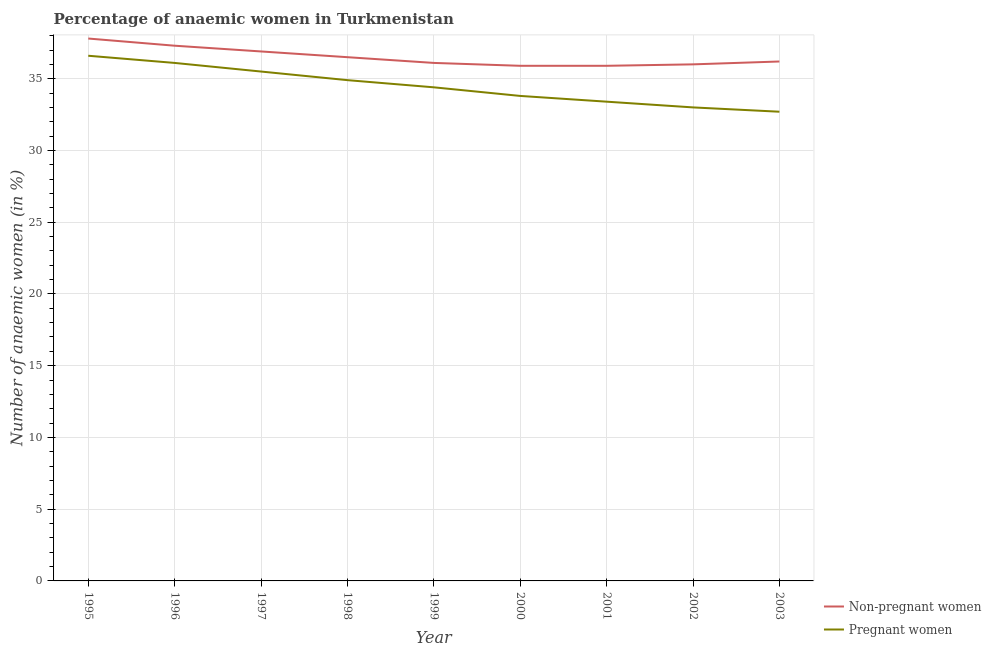What is the percentage of pregnant anaemic women in 2003?
Provide a short and direct response. 32.7. Across all years, what is the maximum percentage of non-pregnant anaemic women?
Offer a terse response. 37.8. Across all years, what is the minimum percentage of non-pregnant anaemic women?
Provide a short and direct response. 35.9. What is the total percentage of pregnant anaemic women in the graph?
Give a very brief answer. 310.4. What is the difference between the percentage of pregnant anaemic women in 1997 and that in 1998?
Ensure brevity in your answer.  0.6. What is the difference between the percentage of non-pregnant anaemic women in 2000 and the percentage of pregnant anaemic women in 1995?
Keep it short and to the point. -0.7. What is the average percentage of non-pregnant anaemic women per year?
Offer a very short reply. 36.51. In the year 2000, what is the difference between the percentage of pregnant anaemic women and percentage of non-pregnant anaemic women?
Provide a succinct answer. -2.1. What is the ratio of the percentage of non-pregnant anaemic women in 2001 to that in 2003?
Your answer should be compact. 0.99. What is the difference between the highest and the lowest percentage of non-pregnant anaemic women?
Provide a short and direct response. 1.9. In how many years, is the percentage of pregnant anaemic women greater than the average percentage of pregnant anaemic women taken over all years?
Offer a terse response. 4. Is the sum of the percentage of non-pregnant anaemic women in 2000 and 2003 greater than the maximum percentage of pregnant anaemic women across all years?
Provide a short and direct response. Yes. Is the percentage of pregnant anaemic women strictly greater than the percentage of non-pregnant anaemic women over the years?
Keep it short and to the point. No. Is the percentage of non-pregnant anaemic women strictly less than the percentage of pregnant anaemic women over the years?
Your response must be concise. No. How many lines are there?
Your answer should be very brief. 2. What is the difference between two consecutive major ticks on the Y-axis?
Make the answer very short. 5. Are the values on the major ticks of Y-axis written in scientific E-notation?
Ensure brevity in your answer.  No. Does the graph contain grids?
Provide a succinct answer. Yes. What is the title of the graph?
Offer a very short reply. Percentage of anaemic women in Turkmenistan. What is the label or title of the Y-axis?
Offer a terse response. Number of anaemic women (in %). What is the Number of anaemic women (in %) in Non-pregnant women in 1995?
Make the answer very short. 37.8. What is the Number of anaemic women (in %) of Pregnant women in 1995?
Offer a terse response. 36.6. What is the Number of anaemic women (in %) in Non-pregnant women in 1996?
Offer a terse response. 37.3. What is the Number of anaemic women (in %) in Pregnant women in 1996?
Make the answer very short. 36.1. What is the Number of anaemic women (in %) of Non-pregnant women in 1997?
Give a very brief answer. 36.9. What is the Number of anaemic women (in %) of Pregnant women in 1997?
Your response must be concise. 35.5. What is the Number of anaemic women (in %) in Non-pregnant women in 1998?
Your response must be concise. 36.5. What is the Number of anaemic women (in %) in Pregnant women in 1998?
Offer a terse response. 34.9. What is the Number of anaemic women (in %) in Non-pregnant women in 1999?
Offer a terse response. 36.1. What is the Number of anaemic women (in %) in Pregnant women in 1999?
Your response must be concise. 34.4. What is the Number of anaemic women (in %) in Non-pregnant women in 2000?
Your answer should be very brief. 35.9. What is the Number of anaemic women (in %) of Pregnant women in 2000?
Provide a succinct answer. 33.8. What is the Number of anaemic women (in %) of Non-pregnant women in 2001?
Offer a terse response. 35.9. What is the Number of anaemic women (in %) in Pregnant women in 2001?
Offer a very short reply. 33.4. What is the Number of anaemic women (in %) in Non-pregnant women in 2002?
Give a very brief answer. 36. What is the Number of anaemic women (in %) of Non-pregnant women in 2003?
Ensure brevity in your answer.  36.2. What is the Number of anaemic women (in %) in Pregnant women in 2003?
Give a very brief answer. 32.7. Across all years, what is the maximum Number of anaemic women (in %) of Non-pregnant women?
Provide a short and direct response. 37.8. Across all years, what is the maximum Number of anaemic women (in %) in Pregnant women?
Your answer should be compact. 36.6. Across all years, what is the minimum Number of anaemic women (in %) of Non-pregnant women?
Provide a short and direct response. 35.9. Across all years, what is the minimum Number of anaemic women (in %) of Pregnant women?
Your response must be concise. 32.7. What is the total Number of anaemic women (in %) of Non-pregnant women in the graph?
Your response must be concise. 328.6. What is the total Number of anaemic women (in %) in Pregnant women in the graph?
Keep it short and to the point. 310.4. What is the difference between the Number of anaemic women (in %) of Non-pregnant women in 1995 and that in 1996?
Ensure brevity in your answer.  0.5. What is the difference between the Number of anaemic women (in %) of Non-pregnant women in 1995 and that in 2000?
Provide a short and direct response. 1.9. What is the difference between the Number of anaemic women (in %) of Pregnant women in 1995 and that in 2000?
Provide a short and direct response. 2.8. What is the difference between the Number of anaemic women (in %) of Non-pregnant women in 1995 and that in 2001?
Your answer should be compact. 1.9. What is the difference between the Number of anaemic women (in %) in Non-pregnant women in 1995 and that in 2002?
Give a very brief answer. 1.8. What is the difference between the Number of anaemic women (in %) of Non-pregnant women in 1995 and that in 2003?
Your answer should be compact. 1.6. What is the difference between the Number of anaemic women (in %) in Pregnant women in 1995 and that in 2003?
Your answer should be compact. 3.9. What is the difference between the Number of anaemic women (in %) of Pregnant women in 1996 and that in 1997?
Ensure brevity in your answer.  0.6. What is the difference between the Number of anaemic women (in %) of Non-pregnant women in 1996 and that in 1998?
Provide a succinct answer. 0.8. What is the difference between the Number of anaemic women (in %) of Pregnant women in 1996 and that in 1998?
Offer a terse response. 1.2. What is the difference between the Number of anaemic women (in %) in Non-pregnant women in 1996 and that in 2003?
Provide a succinct answer. 1.1. What is the difference between the Number of anaemic women (in %) of Pregnant women in 1996 and that in 2003?
Keep it short and to the point. 3.4. What is the difference between the Number of anaemic women (in %) in Non-pregnant women in 1997 and that in 1998?
Your answer should be very brief. 0.4. What is the difference between the Number of anaemic women (in %) in Non-pregnant women in 1997 and that in 1999?
Your response must be concise. 0.8. What is the difference between the Number of anaemic women (in %) of Pregnant women in 1997 and that in 1999?
Make the answer very short. 1.1. What is the difference between the Number of anaemic women (in %) in Non-pregnant women in 1997 and that in 2000?
Provide a short and direct response. 1. What is the difference between the Number of anaemic women (in %) in Pregnant women in 1997 and that in 2000?
Give a very brief answer. 1.7. What is the difference between the Number of anaemic women (in %) of Non-pregnant women in 1997 and that in 2001?
Offer a very short reply. 1. What is the difference between the Number of anaemic women (in %) of Non-pregnant women in 1997 and that in 2002?
Provide a short and direct response. 0.9. What is the difference between the Number of anaemic women (in %) in Pregnant women in 1997 and that in 2002?
Offer a very short reply. 2.5. What is the difference between the Number of anaemic women (in %) of Non-pregnant women in 1998 and that in 1999?
Offer a very short reply. 0.4. What is the difference between the Number of anaemic women (in %) in Non-pregnant women in 1998 and that in 2001?
Your answer should be very brief. 0.6. What is the difference between the Number of anaemic women (in %) of Pregnant women in 1998 and that in 2001?
Give a very brief answer. 1.5. What is the difference between the Number of anaemic women (in %) in Non-pregnant women in 1998 and that in 2002?
Give a very brief answer. 0.5. What is the difference between the Number of anaemic women (in %) in Pregnant women in 1998 and that in 2002?
Give a very brief answer. 1.9. What is the difference between the Number of anaemic women (in %) of Non-pregnant women in 1998 and that in 2003?
Make the answer very short. 0.3. What is the difference between the Number of anaemic women (in %) in Pregnant women in 1999 and that in 2000?
Offer a very short reply. 0.6. What is the difference between the Number of anaemic women (in %) in Non-pregnant women in 1999 and that in 2002?
Offer a terse response. 0.1. What is the difference between the Number of anaemic women (in %) of Pregnant women in 1999 and that in 2002?
Provide a succinct answer. 1.4. What is the difference between the Number of anaemic women (in %) in Pregnant women in 1999 and that in 2003?
Provide a succinct answer. 1.7. What is the difference between the Number of anaemic women (in %) of Non-pregnant women in 2000 and that in 2001?
Your answer should be very brief. 0. What is the difference between the Number of anaemic women (in %) in Non-pregnant women in 2000 and that in 2003?
Provide a succinct answer. -0.3. What is the difference between the Number of anaemic women (in %) in Non-pregnant women in 2001 and that in 2002?
Give a very brief answer. -0.1. What is the difference between the Number of anaemic women (in %) of Non-pregnant women in 2001 and that in 2003?
Make the answer very short. -0.3. What is the difference between the Number of anaemic women (in %) of Pregnant women in 2001 and that in 2003?
Offer a very short reply. 0.7. What is the difference between the Number of anaemic women (in %) of Non-pregnant women in 1995 and the Number of anaemic women (in %) of Pregnant women in 1997?
Provide a short and direct response. 2.3. What is the difference between the Number of anaemic women (in %) in Non-pregnant women in 1995 and the Number of anaemic women (in %) in Pregnant women in 1998?
Offer a very short reply. 2.9. What is the difference between the Number of anaemic women (in %) in Non-pregnant women in 1995 and the Number of anaemic women (in %) in Pregnant women in 2001?
Your answer should be very brief. 4.4. What is the difference between the Number of anaemic women (in %) in Non-pregnant women in 1995 and the Number of anaemic women (in %) in Pregnant women in 2003?
Your answer should be very brief. 5.1. What is the difference between the Number of anaemic women (in %) in Non-pregnant women in 1996 and the Number of anaemic women (in %) in Pregnant women in 1998?
Give a very brief answer. 2.4. What is the difference between the Number of anaemic women (in %) of Non-pregnant women in 1996 and the Number of anaemic women (in %) of Pregnant women in 2000?
Your response must be concise. 3.5. What is the difference between the Number of anaemic women (in %) in Non-pregnant women in 1996 and the Number of anaemic women (in %) in Pregnant women in 2001?
Keep it short and to the point. 3.9. What is the difference between the Number of anaemic women (in %) of Non-pregnant women in 1996 and the Number of anaemic women (in %) of Pregnant women in 2002?
Offer a very short reply. 4.3. What is the difference between the Number of anaemic women (in %) of Non-pregnant women in 1997 and the Number of anaemic women (in %) of Pregnant women in 1999?
Make the answer very short. 2.5. What is the difference between the Number of anaemic women (in %) of Non-pregnant women in 1997 and the Number of anaemic women (in %) of Pregnant women in 2000?
Your response must be concise. 3.1. What is the difference between the Number of anaemic women (in %) in Non-pregnant women in 1997 and the Number of anaemic women (in %) in Pregnant women in 2001?
Provide a succinct answer. 3.5. What is the difference between the Number of anaemic women (in %) of Non-pregnant women in 1997 and the Number of anaemic women (in %) of Pregnant women in 2002?
Provide a succinct answer. 3.9. What is the difference between the Number of anaemic women (in %) of Non-pregnant women in 1998 and the Number of anaemic women (in %) of Pregnant women in 2002?
Offer a terse response. 3.5. What is the difference between the Number of anaemic women (in %) in Non-pregnant women in 1999 and the Number of anaemic women (in %) in Pregnant women in 2001?
Ensure brevity in your answer.  2.7. What is the difference between the Number of anaemic women (in %) of Non-pregnant women in 1999 and the Number of anaemic women (in %) of Pregnant women in 2002?
Provide a succinct answer. 3.1. What is the difference between the Number of anaemic women (in %) in Non-pregnant women in 1999 and the Number of anaemic women (in %) in Pregnant women in 2003?
Your answer should be very brief. 3.4. What is the difference between the Number of anaemic women (in %) of Non-pregnant women in 2001 and the Number of anaemic women (in %) of Pregnant women in 2002?
Ensure brevity in your answer.  2.9. What is the average Number of anaemic women (in %) of Non-pregnant women per year?
Ensure brevity in your answer.  36.51. What is the average Number of anaemic women (in %) of Pregnant women per year?
Your answer should be compact. 34.49. In the year 1996, what is the difference between the Number of anaemic women (in %) in Non-pregnant women and Number of anaemic women (in %) in Pregnant women?
Give a very brief answer. 1.2. In the year 1999, what is the difference between the Number of anaemic women (in %) of Non-pregnant women and Number of anaemic women (in %) of Pregnant women?
Offer a very short reply. 1.7. In the year 2003, what is the difference between the Number of anaemic women (in %) of Non-pregnant women and Number of anaemic women (in %) of Pregnant women?
Your response must be concise. 3.5. What is the ratio of the Number of anaemic women (in %) of Non-pregnant women in 1995 to that in 1996?
Make the answer very short. 1.01. What is the ratio of the Number of anaemic women (in %) of Pregnant women in 1995 to that in 1996?
Offer a very short reply. 1.01. What is the ratio of the Number of anaemic women (in %) of Non-pregnant women in 1995 to that in 1997?
Offer a very short reply. 1.02. What is the ratio of the Number of anaemic women (in %) in Pregnant women in 1995 to that in 1997?
Your answer should be very brief. 1.03. What is the ratio of the Number of anaemic women (in %) in Non-pregnant women in 1995 to that in 1998?
Give a very brief answer. 1.04. What is the ratio of the Number of anaemic women (in %) of Pregnant women in 1995 to that in 1998?
Make the answer very short. 1.05. What is the ratio of the Number of anaemic women (in %) of Non-pregnant women in 1995 to that in 1999?
Provide a short and direct response. 1.05. What is the ratio of the Number of anaemic women (in %) in Pregnant women in 1995 to that in 1999?
Offer a very short reply. 1.06. What is the ratio of the Number of anaemic women (in %) of Non-pregnant women in 1995 to that in 2000?
Your answer should be compact. 1.05. What is the ratio of the Number of anaemic women (in %) in Pregnant women in 1995 to that in 2000?
Keep it short and to the point. 1.08. What is the ratio of the Number of anaemic women (in %) in Non-pregnant women in 1995 to that in 2001?
Ensure brevity in your answer.  1.05. What is the ratio of the Number of anaemic women (in %) of Pregnant women in 1995 to that in 2001?
Make the answer very short. 1.1. What is the ratio of the Number of anaemic women (in %) of Pregnant women in 1995 to that in 2002?
Provide a short and direct response. 1.11. What is the ratio of the Number of anaemic women (in %) of Non-pregnant women in 1995 to that in 2003?
Provide a short and direct response. 1.04. What is the ratio of the Number of anaemic women (in %) in Pregnant women in 1995 to that in 2003?
Ensure brevity in your answer.  1.12. What is the ratio of the Number of anaemic women (in %) of Non-pregnant women in 1996 to that in 1997?
Provide a succinct answer. 1.01. What is the ratio of the Number of anaemic women (in %) in Pregnant women in 1996 to that in 1997?
Provide a short and direct response. 1.02. What is the ratio of the Number of anaemic women (in %) of Non-pregnant women in 1996 to that in 1998?
Provide a short and direct response. 1.02. What is the ratio of the Number of anaemic women (in %) of Pregnant women in 1996 to that in 1998?
Offer a terse response. 1.03. What is the ratio of the Number of anaemic women (in %) in Non-pregnant women in 1996 to that in 1999?
Your answer should be very brief. 1.03. What is the ratio of the Number of anaemic women (in %) of Pregnant women in 1996 to that in 1999?
Provide a short and direct response. 1.05. What is the ratio of the Number of anaemic women (in %) in Non-pregnant women in 1996 to that in 2000?
Provide a short and direct response. 1.04. What is the ratio of the Number of anaemic women (in %) in Pregnant women in 1996 to that in 2000?
Make the answer very short. 1.07. What is the ratio of the Number of anaemic women (in %) in Non-pregnant women in 1996 to that in 2001?
Provide a short and direct response. 1.04. What is the ratio of the Number of anaemic women (in %) of Pregnant women in 1996 to that in 2001?
Make the answer very short. 1.08. What is the ratio of the Number of anaemic women (in %) of Non-pregnant women in 1996 to that in 2002?
Provide a succinct answer. 1.04. What is the ratio of the Number of anaemic women (in %) of Pregnant women in 1996 to that in 2002?
Your answer should be very brief. 1.09. What is the ratio of the Number of anaemic women (in %) of Non-pregnant women in 1996 to that in 2003?
Make the answer very short. 1.03. What is the ratio of the Number of anaemic women (in %) in Pregnant women in 1996 to that in 2003?
Your answer should be very brief. 1.1. What is the ratio of the Number of anaemic women (in %) of Non-pregnant women in 1997 to that in 1998?
Make the answer very short. 1.01. What is the ratio of the Number of anaemic women (in %) in Pregnant women in 1997 to that in 1998?
Your answer should be compact. 1.02. What is the ratio of the Number of anaemic women (in %) of Non-pregnant women in 1997 to that in 1999?
Provide a succinct answer. 1.02. What is the ratio of the Number of anaemic women (in %) in Pregnant women in 1997 to that in 1999?
Give a very brief answer. 1.03. What is the ratio of the Number of anaemic women (in %) in Non-pregnant women in 1997 to that in 2000?
Your answer should be compact. 1.03. What is the ratio of the Number of anaemic women (in %) in Pregnant women in 1997 to that in 2000?
Give a very brief answer. 1.05. What is the ratio of the Number of anaemic women (in %) in Non-pregnant women in 1997 to that in 2001?
Offer a very short reply. 1.03. What is the ratio of the Number of anaemic women (in %) of Pregnant women in 1997 to that in 2001?
Your answer should be compact. 1.06. What is the ratio of the Number of anaemic women (in %) in Non-pregnant women in 1997 to that in 2002?
Your answer should be compact. 1.02. What is the ratio of the Number of anaemic women (in %) of Pregnant women in 1997 to that in 2002?
Ensure brevity in your answer.  1.08. What is the ratio of the Number of anaemic women (in %) of Non-pregnant women in 1997 to that in 2003?
Give a very brief answer. 1.02. What is the ratio of the Number of anaemic women (in %) in Pregnant women in 1997 to that in 2003?
Your answer should be very brief. 1.09. What is the ratio of the Number of anaemic women (in %) of Non-pregnant women in 1998 to that in 1999?
Your answer should be compact. 1.01. What is the ratio of the Number of anaemic women (in %) of Pregnant women in 1998 to that in 1999?
Offer a very short reply. 1.01. What is the ratio of the Number of anaemic women (in %) in Non-pregnant women in 1998 to that in 2000?
Ensure brevity in your answer.  1.02. What is the ratio of the Number of anaemic women (in %) in Pregnant women in 1998 to that in 2000?
Your answer should be very brief. 1.03. What is the ratio of the Number of anaemic women (in %) in Non-pregnant women in 1998 to that in 2001?
Your answer should be very brief. 1.02. What is the ratio of the Number of anaemic women (in %) of Pregnant women in 1998 to that in 2001?
Give a very brief answer. 1.04. What is the ratio of the Number of anaemic women (in %) of Non-pregnant women in 1998 to that in 2002?
Ensure brevity in your answer.  1.01. What is the ratio of the Number of anaemic women (in %) of Pregnant women in 1998 to that in 2002?
Keep it short and to the point. 1.06. What is the ratio of the Number of anaemic women (in %) of Non-pregnant women in 1998 to that in 2003?
Keep it short and to the point. 1.01. What is the ratio of the Number of anaemic women (in %) in Pregnant women in 1998 to that in 2003?
Offer a very short reply. 1.07. What is the ratio of the Number of anaemic women (in %) in Non-pregnant women in 1999 to that in 2000?
Give a very brief answer. 1.01. What is the ratio of the Number of anaemic women (in %) in Pregnant women in 1999 to that in 2000?
Your answer should be compact. 1.02. What is the ratio of the Number of anaemic women (in %) of Non-pregnant women in 1999 to that in 2001?
Ensure brevity in your answer.  1.01. What is the ratio of the Number of anaemic women (in %) of Pregnant women in 1999 to that in 2001?
Provide a succinct answer. 1.03. What is the ratio of the Number of anaemic women (in %) of Pregnant women in 1999 to that in 2002?
Your answer should be very brief. 1.04. What is the ratio of the Number of anaemic women (in %) of Non-pregnant women in 1999 to that in 2003?
Provide a succinct answer. 1. What is the ratio of the Number of anaemic women (in %) in Pregnant women in 1999 to that in 2003?
Keep it short and to the point. 1.05. What is the ratio of the Number of anaemic women (in %) in Pregnant women in 2000 to that in 2002?
Provide a short and direct response. 1.02. What is the ratio of the Number of anaemic women (in %) of Pregnant women in 2000 to that in 2003?
Offer a terse response. 1.03. What is the ratio of the Number of anaemic women (in %) in Pregnant women in 2001 to that in 2002?
Give a very brief answer. 1.01. What is the ratio of the Number of anaemic women (in %) of Pregnant women in 2001 to that in 2003?
Your answer should be compact. 1.02. What is the ratio of the Number of anaemic women (in %) in Non-pregnant women in 2002 to that in 2003?
Your response must be concise. 0.99. What is the ratio of the Number of anaemic women (in %) in Pregnant women in 2002 to that in 2003?
Your answer should be very brief. 1.01. What is the difference between the highest and the lowest Number of anaemic women (in %) in Non-pregnant women?
Give a very brief answer. 1.9. What is the difference between the highest and the lowest Number of anaemic women (in %) of Pregnant women?
Offer a terse response. 3.9. 